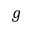Convert formula to latex. <formula><loc_0><loc_0><loc_500><loc_500>g</formula> 